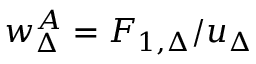<formula> <loc_0><loc_0><loc_500><loc_500>\begin{array} { r } { w _ { \Delta } ^ { A } = F _ { 1 , \Delta } / u _ { \Delta } } \end{array}</formula> 